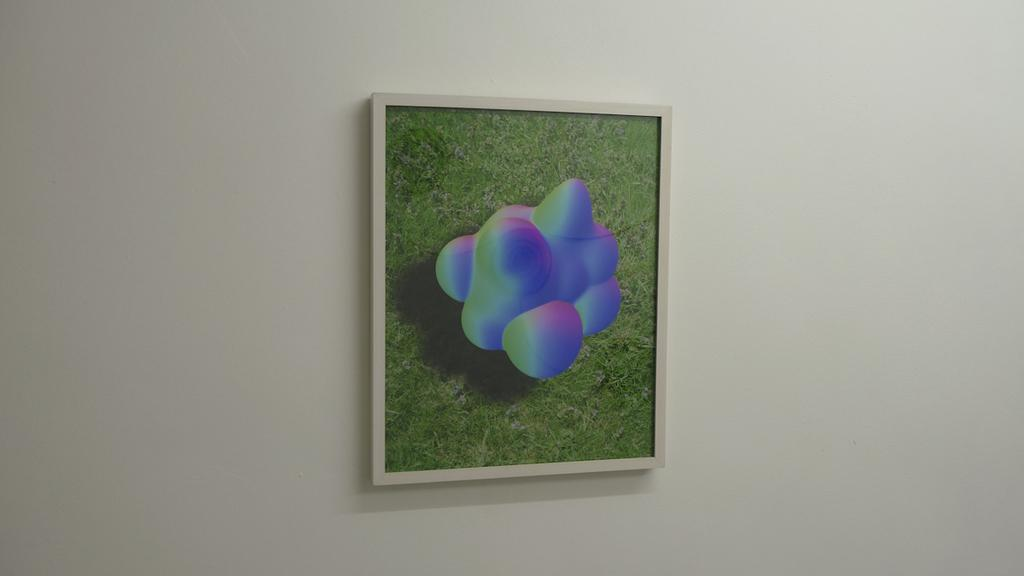What can be seen on the wall in the image? There is a photo frame on the wall in the image. Can you describe the wall in the image? The wall is a flat surface with a photo frame attached to it. What type of celery is being used to protest in the image? There is no celery or protest present in the image; it only features a wall with a photo frame on it. 